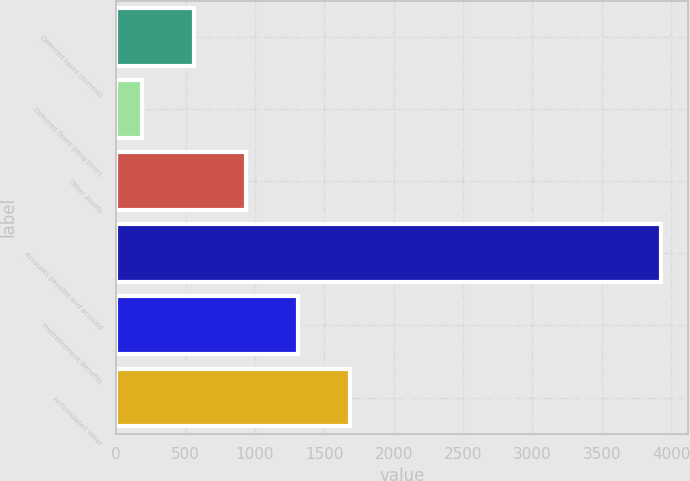Convert chart. <chart><loc_0><loc_0><loc_500><loc_500><bar_chart><fcel>Deferred taxes (current)<fcel>Deferred Taxes (long-term)<fcel>Other Assets<fcel>Accounts payable and accrued<fcel>Postretirement Benefits<fcel>Accumulated other<nl><fcel>559.9<fcel>186<fcel>933.8<fcel>3925<fcel>1307.7<fcel>1681.6<nl></chart> 